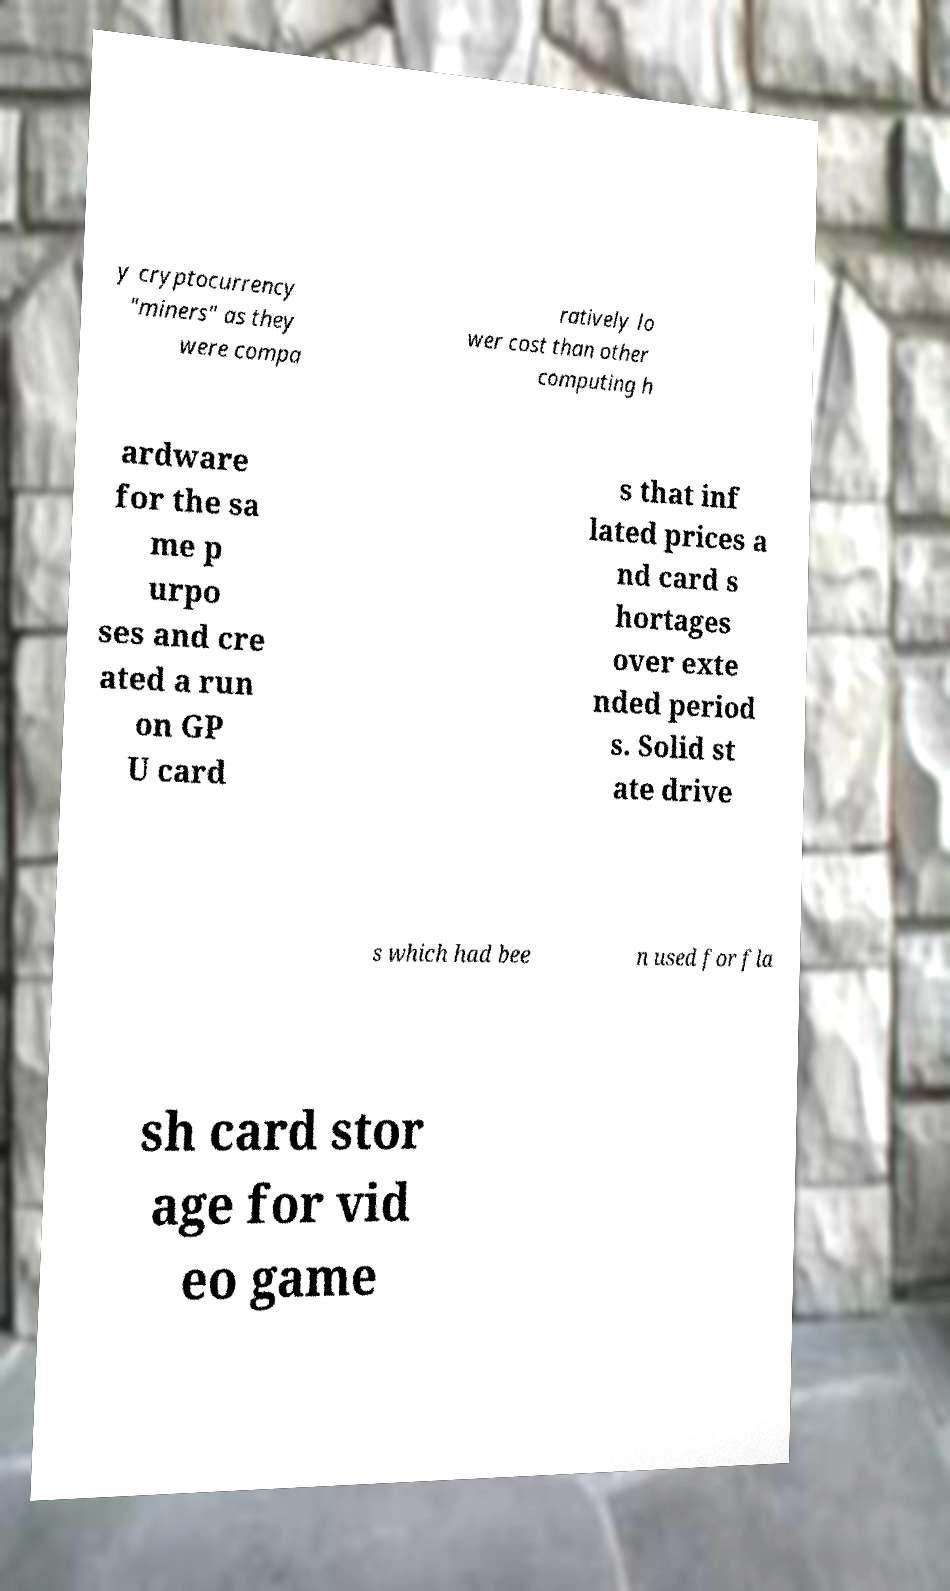There's text embedded in this image that I need extracted. Can you transcribe it verbatim? y cryptocurrency "miners" as they were compa ratively lo wer cost than other computing h ardware for the sa me p urpo ses and cre ated a run on GP U card s that inf lated prices a nd card s hortages over exte nded period s. Solid st ate drive s which had bee n used for fla sh card stor age for vid eo game 